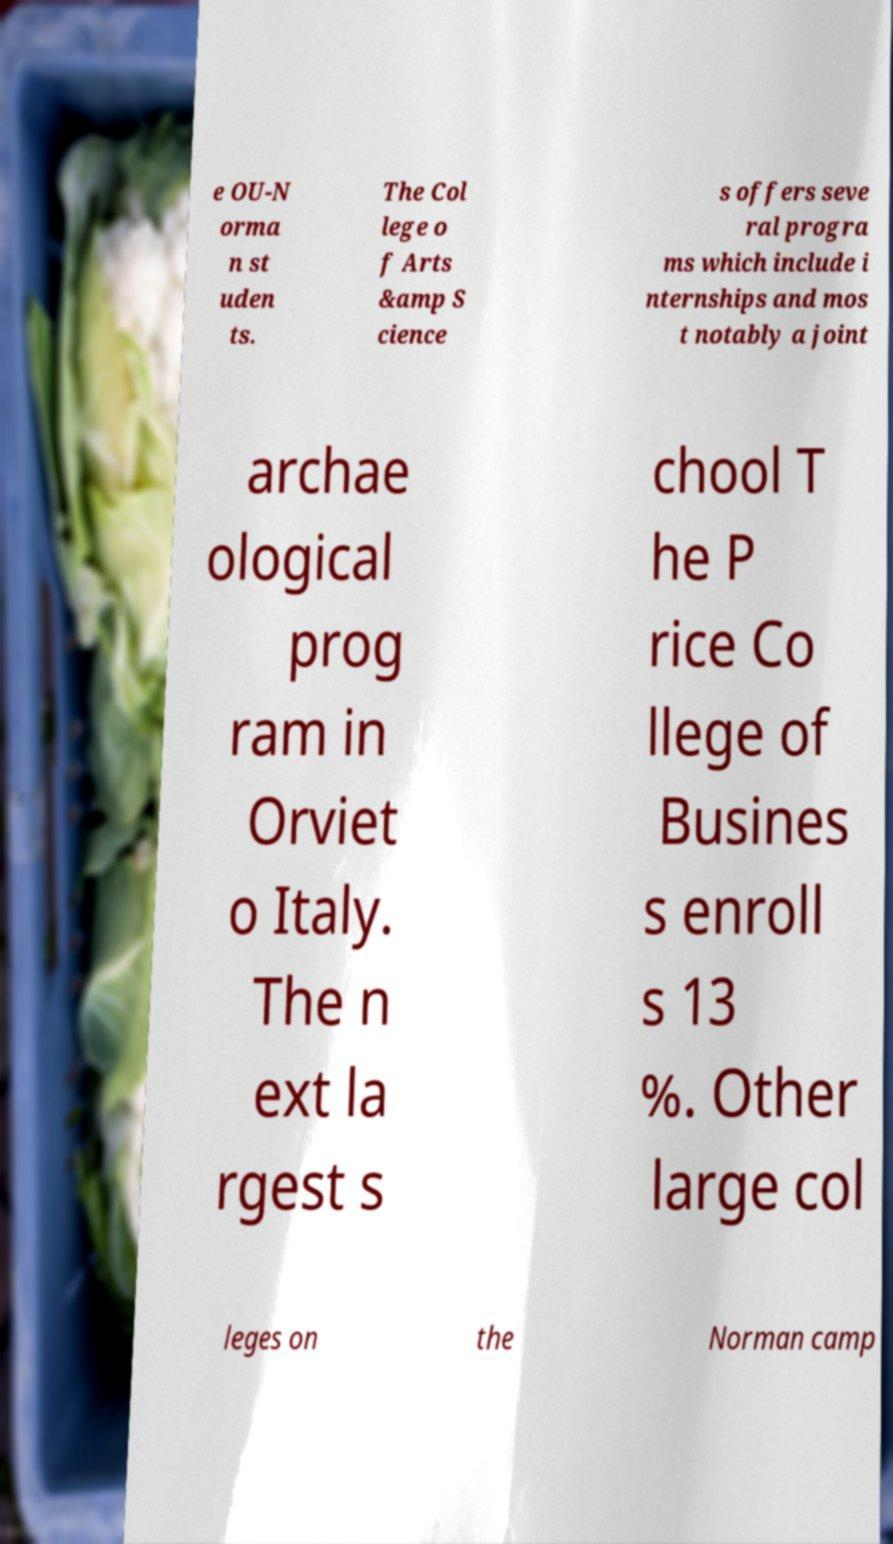Could you extract and type out the text from this image? e OU-N orma n st uden ts. The Col lege o f Arts &amp S cience s offers seve ral progra ms which include i nternships and mos t notably a joint archae ological prog ram in Orviet o Italy. The n ext la rgest s chool T he P rice Co llege of Busines s enroll s 13 %. Other large col leges on the Norman camp 